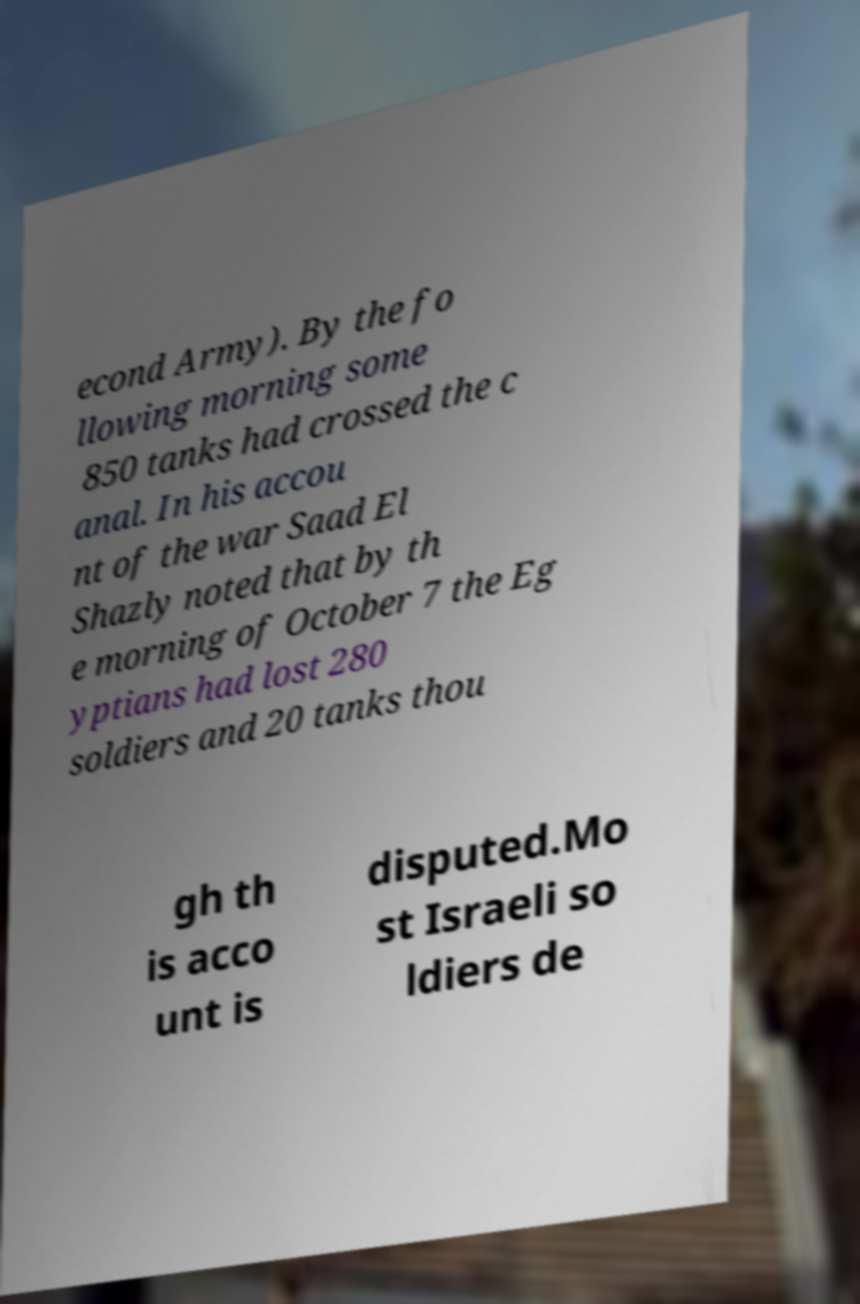Could you assist in decoding the text presented in this image and type it out clearly? econd Army). By the fo llowing morning some 850 tanks had crossed the c anal. In his accou nt of the war Saad El Shazly noted that by th e morning of October 7 the Eg yptians had lost 280 soldiers and 20 tanks thou gh th is acco unt is disputed.Mo st Israeli so ldiers de 